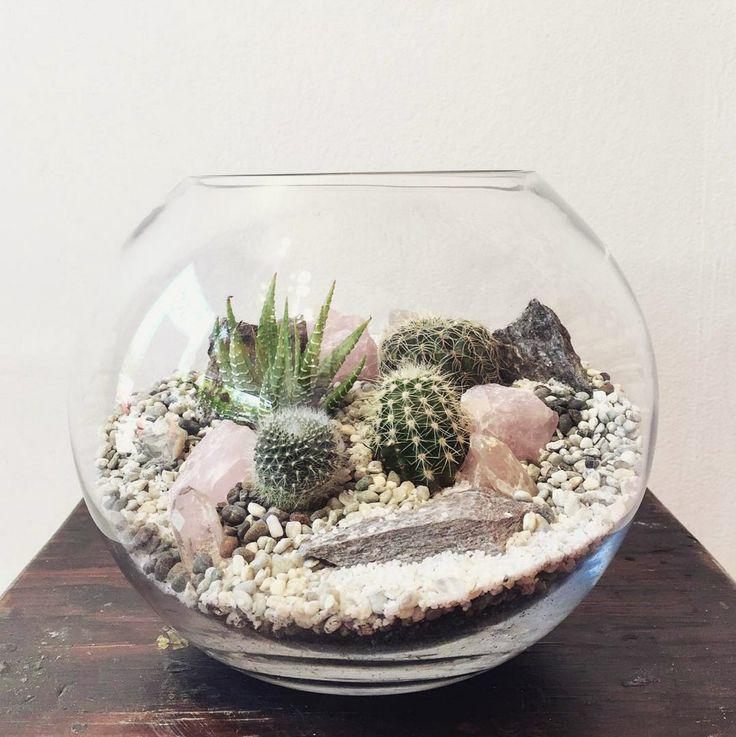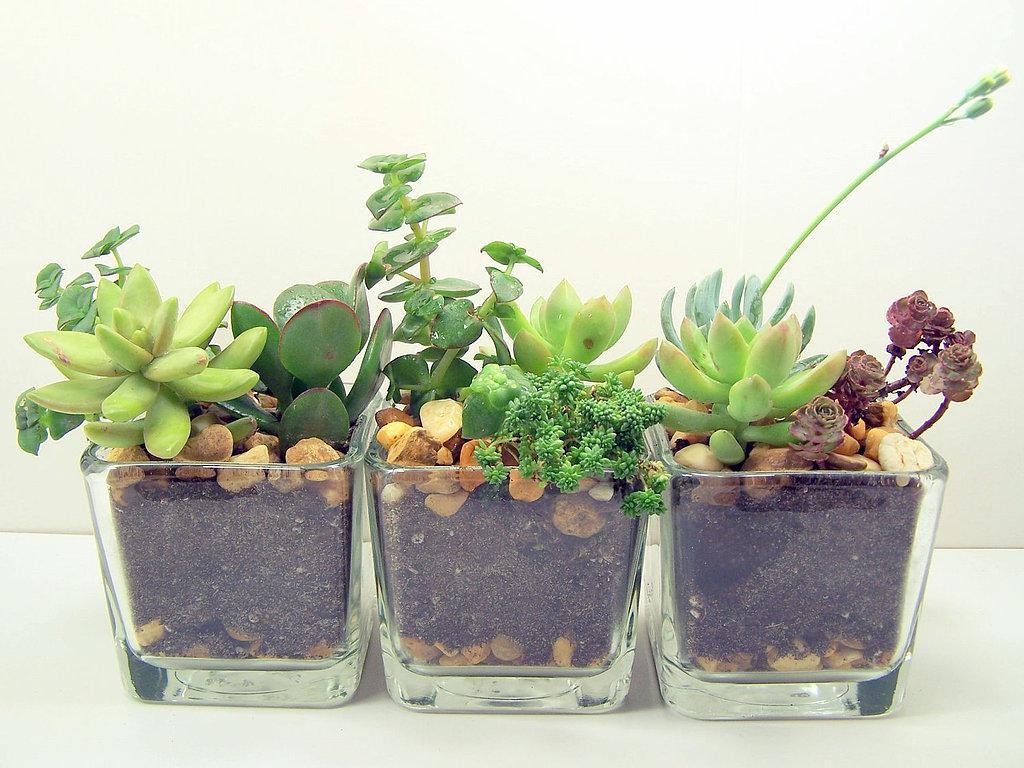The first image is the image on the left, the second image is the image on the right. For the images shown, is this caption "There are at least two square glass holders with small green shrubbery and rock." true? Answer yes or no. Yes. The first image is the image on the left, the second image is the image on the right. Assess this claim about the two images: "There are more containers holding plants in the image on the left.". Correct or not? Answer yes or no. No. 